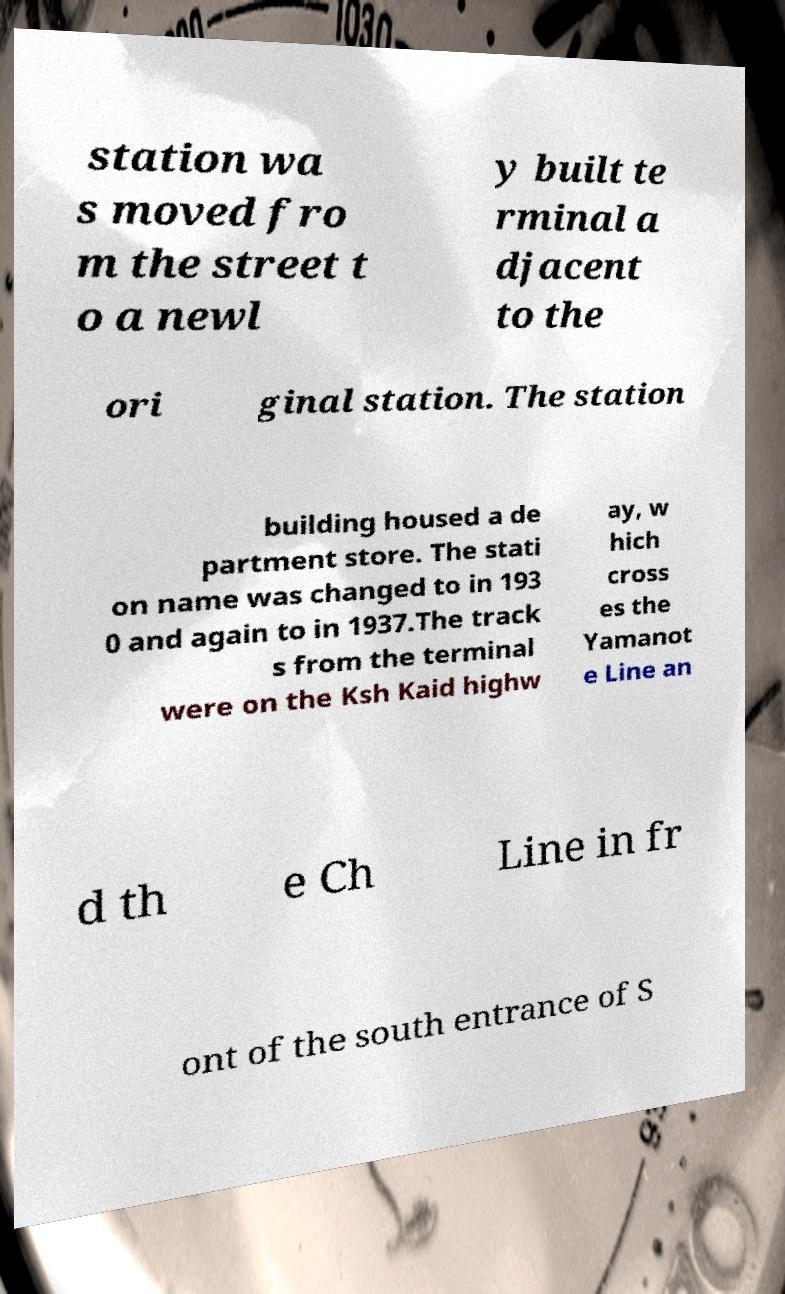What messages or text are displayed in this image? I need them in a readable, typed format. station wa s moved fro m the street t o a newl y built te rminal a djacent to the ori ginal station. The station building housed a de partment store. The stati on name was changed to in 193 0 and again to in 1937.The track s from the terminal were on the Ksh Kaid highw ay, w hich cross es the Yamanot e Line an d th e Ch Line in fr ont of the south entrance of S 